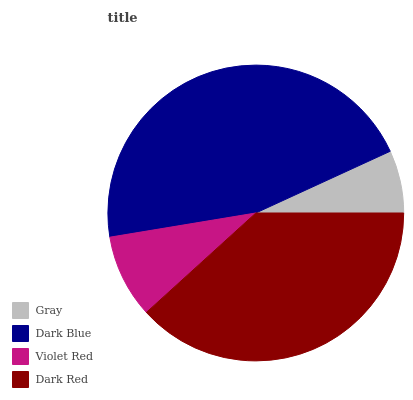Is Gray the minimum?
Answer yes or no. Yes. Is Dark Blue the maximum?
Answer yes or no. Yes. Is Violet Red the minimum?
Answer yes or no. No. Is Violet Red the maximum?
Answer yes or no. No. Is Dark Blue greater than Violet Red?
Answer yes or no. Yes. Is Violet Red less than Dark Blue?
Answer yes or no. Yes. Is Violet Red greater than Dark Blue?
Answer yes or no. No. Is Dark Blue less than Violet Red?
Answer yes or no. No. Is Dark Red the high median?
Answer yes or no. Yes. Is Violet Red the low median?
Answer yes or no. Yes. Is Gray the high median?
Answer yes or no. No. Is Dark Blue the low median?
Answer yes or no. No. 